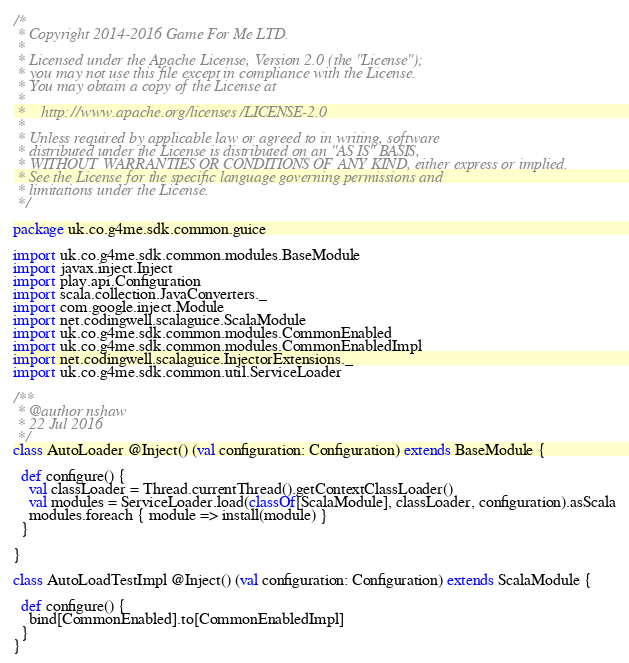<code> <loc_0><loc_0><loc_500><loc_500><_Scala_>/*
 * Copyright 2014-2016 Game For Me LTD.
 *
 * Licensed under the Apache License, Version 2.0 (the "License");
 * you may not use this file except in compliance with the License.
 * You may obtain a copy of the License at
 *
 *    http://www.apache.org/licenses/LICENSE-2.0
 *
 * Unless required by applicable law or agreed to in writing, software
 * distributed under the License is distributed on an "AS IS" BASIS,
 * WITHOUT WARRANTIES OR CONDITIONS OF ANY KIND, either express or implied.
 * See the License for the specific language governing permissions and
 * limitations under the License.
 */

package uk.co.g4me.sdk.common.guice

import uk.co.g4me.sdk.common.modules.BaseModule
import javax.inject.Inject
import play.api.Configuration
import scala.collection.JavaConverters._
import com.google.inject.Module
import net.codingwell.scalaguice.ScalaModule
import uk.co.g4me.sdk.common.modules.CommonEnabled
import uk.co.g4me.sdk.common.modules.CommonEnabledImpl
import net.codingwell.scalaguice.InjectorExtensions._
import uk.co.g4me.sdk.common.util.ServiceLoader

/**
 * @author nshaw
 * 22 Jul 2016
 */
class AutoLoader @Inject() (val configuration: Configuration) extends BaseModule {

  def configure() {
    val classLoader = Thread.currentThread().getContextClassLoader()
    val modules = ServiceLoader.load(classOf[ScalaModule], classLoader, configuration).asScala
    modules.foreach { module => install(module) }
  }

}

class AutoLoadTestImpl @Inject() (val configuration: Configuration) extends ScalaModule {

  def configure() {
    bind[CommonEnabled].to[CommonEnabledImpl]
  }
}</code> 